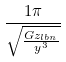Convert formula to latex. <formula><loc_0><loc_0><loc_500><loc_500>\frac { 1 \pi } { \sqrt { \frac { G z _ { l b n } } { y ^ { 3 } } } }</formula> 